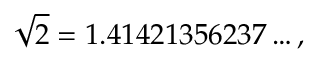Convert formula to latex. <formula><loc_0><loc_0><loc_500><loc_500>{ \sqrt { 2 } } = 1 . 4 1 4 2 1 3 5 6 2 3 7 \dots ,</formula> 